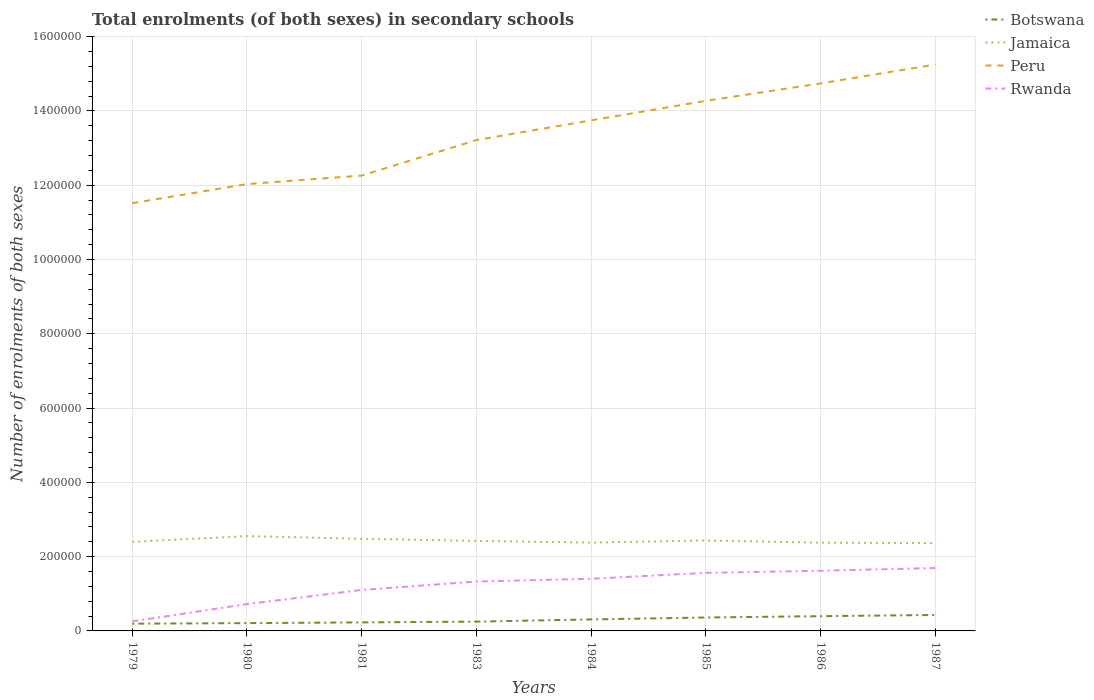Does the line corresponding to Jamaica intersect with the line corresponding to Botswana?
Provide a short and direct response. No. Is the number of lines equal to the number of legend labels?
Keep it short and to the point. Yes. Across all years, what is the maximum number of enrolments in secondary schools in Jamaica?
Keep it short and to the point. 2.36e+05. What is the total number of enrolments in secondary schools in Rwanda in the graph?
Your answer should be very brief. -1.15e+05. What is the difference between the highest and the second highest number of enrolments in secondary schools in Peru?
Ensure brevity in your answer.  3.73e+05. What is the difference between the highest and the lowest number of enrolments in secondary schools in Rwanda?
Your answer should be compact. 5. Is the number of enrolments in secondary schools in Peru strictly greater than the number of enrolments in secondary schools in Rwanda over the years?
Keep it short and to the point. No. Are the values on the major ticks of Y-axis written in scientific E-notation?
Provide a short and direct response. No. Where does the legend appear in the graph?
Keep it short and to the point. Top right. How are the legend labels stacked?
Give a very brief answer. Vertical. What is the title of the graph?
Make the answer very short. Total enrolments (of both sexes) in secondary schools. Does "High income: OECD" appear as one of the legend labels in the graph?
Your answer should be very brief. No. What is the label or title of the Y-axis?
Give a very brief answer. Number of enrolments of both sexes. What is the Number of enrolments of both sexes of Botswana in 1979?
Ensure brevity in your answer.  1.95e+04. What is the Number of enrolments of both sexes of Jamaica in 1979?
Offer a very short reply. 2.40e+05. What is the Number of enrolments of both sexes of Peru in 1979?
Provide a short and direct response. 1.15e+06. What is the Number of enrolments of both sexes of Rwanda in 1979?
Provide a succinct answer. 2.56e+04. What is the Number of enrolments of both sexes in Botswana in 1980?
Provide a short and direct response. 2.10e+04. What is the Number of enrolments of both sexes of Jamaica in 1980?
Offer a very short reply. 2.55e+05. What is the Number of enrolments of both sexes of Peru in 1980?
Your answer should be compact. 1.20e+06. What is the Number of enrolments of both sexes in Rwanda in 1980?
Your answer should be very brief. 7.22e+04. What is the Number of enrolments of both sexes in Botswana in 1981?
Offer a very short reply. 2.30e+04. What is the Number of enrolments of both sexes of Jamaica in 1981?
Keep it short and to the point. 2.48e+05. What is the Number of enrolments of both sexes in Peru in 1981?
Provide a succinct answer. 1.23e+06. What is the Number of enrolments of both sexes of Rwanda in 1981?
Your response must be concise. 1.10e+05. What is the Number of enrolments of both sexes in Botswana in 1983?
Your answer should be very brief. 2.50e+04. What is the Number of enrolments of both sexes of Jamaica in 1983?
Your answer should be very brief. 2.42e+05. What is the Number of enrolments of both sexes of Peru in 1983?
Your response must be concise. 1.32e+06. What is the Number of enrolments of both sexes of Rwanda in 1983?
Ensure brevity in your answer.  1.33e+05. What is the Number of enrolments of both sexes in Botswana in 1984?
Provide a short and direct response. 3.09e+04. What is the Number of enrolments of both sexes of Jamaica in 1984?
Provide a succinct answer. 2.38e+05. What is the Number of enrolments of both sexes of Peru in 1984?
Your answer should be very brief. 1.37e+06. What is the Number of enrolments of both sexes of Rwanda in 1984?
Provide a short and direct response. 1.40e+05. What is the Number of enrolments of both sexes of Botswana in 1985?
Make the answer very short. 3.61e+04. What is the Number of enrolments of both sexes in Jamaica in 1985?
Your answer should be compact. 2.44e+05. What is the Number of enrolments of both sexes in Peru in 1985?
Keep it short and to the point. 1.43e+06. What is the Number of enrolments of both sexes of Rwanda in 1985?
Offer a terse response. 1.56e+05. What is the Number of enrolments of both sexes in Botswana in 1986?
Keep it short and to the point. 3.97e+04. What is the Number of enrolments of both sexes of Jamaica in 1986?
Your answer should be compact. 2.38e+05. What is the Number of enrolments of both sexes in Peru in 1986?
Provide a succinct answer. 1.47e+06. What is the Number of enrolments of both sexes of Rwanda in 1986?
Your response must be concise. 1.62e+05. What is the Number of enrolments of both sexes of Botswana in 1987?
Your answer should be compact. 4.30e+04. What is the Number of enrolments of both sexes in Jamaica in 1987?
Your answer should be compact. 2.36e+05. What is the Number of enrolments of both sexes in Peru in 1987?
Your answer should be compact. 1.53e+06. What is the Number of enrolments of both sexes in Rwanda in 1987?
Provide a succinct answer. 1.69e+05. Across all years, what is the maximum Number of enrolments of both sexes of Botswana?
Make the answer very short. 4.30e+04. Across all years, what is the maximum Number of enrolments of both sexes of Jamaica?
Your answer should be very brief. 2.55e+05. Across all years, what is the maximum Number of enrolments of both sexes of Peru?
Offer a very short reply. 1.53e+06. Across all years, what is the maximum Number of enrolments of both sexes of Rwanda?
Your answer should be very brief. 1.69e+05. Across all years, what is the minimum Number of enrolments of both sexes of Botswana?
Your response must be concise. 1.95e+04. Across all years, what is the minimum Number of enrolments of both sexes in Jamaica?
Provide a short and direct response. 2.36e+05. Across all years, what is the minimum Number of enrolments of both sexes of Peru?
Ensure brevity in your answer.  1.15e+06. Across all years, what is the minimum Number of enrolments of both sexes in Rwanda?
Your answer should be very brief. 2.56e+04. What is the total Number of enrolments of both sexes of Botswana in the graph?
Keep it short and to the point. 2.38e+05. What is the total Number of enrolments of both sexes in Jamaica in the graph?
Make the answer very short. 1.94e+06. What is the total Number of enrolments of both sexes of Peru in the graph?
Offer a terse response. 1.07e+07. What is the total Number of enrolments of both sexes of Rwanda in the graph?
Offer a terse response. 9.69e+05. What is the difference between the Number of enrolments of both sexes of Botswana in 1979 and that in 1980?
Provide a succinct answer. -1431. What is the difference between the Number of enrolments of both sexes in Jamaica in 1979 and that in 1980?
Keep it short and to the point. -1.55e+04. What is the difference between the Number of enrolments of both sexes in Peru in 1979 and that in 1980?
Keep it short and to the point. -5.14e+04. What is the difference between the Number of enrolments of both sexes in Rwanda in 1979 and that in 1980?
Ensure brevity in your answer.  -4.66e+04. What is the difference between the Number of enrolments of both sexes in Botswana in 1979 and that in 1981?
Keep it short and to the point. -3424. What is the difference between the Number of enrolments of both sexes in Jamaica in 1979 and that in 1981?
Provide a short and direct response. -8242. What is the difference between the Number of enrolments of both sexes of Peru in 1979 and that in 1981?
Provide a short and direct response. -7.44e+04. What is the difference between the Number of enrolments of both sexes in Rwanda in 1979 and that in 1981?
Provide a short and direct response. -8.47e+04. What is the difference between the Number of enrolments of both sexes of Botswana in 1979 and that in 1983?
Offer a very short reply. -5472. What is the difference between the Number of enrolments of both sexes in Jamaica in 1979 and that in 1983?
Your response must be concise. -2630. What is the difference between the Number of enrolments of both sexes in Peru in 1979 and that in 1983?
Offer a very short reply. -1.70e+05. What is the difference between the Number of enrolments of both sexes in Rwanda in 1979 and that in 1983?
Ensure brevity in your answer.  -1.07e+05. What is the difference between the Number of enrolments of both sexes of Botswana in 1979 and that in 1984?
Provide a short and direct response. -1.14e+04. What is the difference between the Number of enrolments of both sexes of Jamaica in 1979 and that in 1984?
Keep it short and to the point. 2001. What is the difference between the Number of enrolments of both sexes of Peru in 1979 and that in 1984?
Offer a very short reply. -2.23e+05. What is the difference between the Number of enrolments of both sexes in Rwanda in 1979 and that in 1984?
Provide a succinct answer. -1.15e+05. What is the difference between the Number of enrolments of both sexes of Botswana in 1979 and that in 1985?
Offer a very short reply. -1.66e+04. What is the difference between the Number of enrolments of both sexes in Jamaica in 1979 and that in 1985?
Keep it short and to the point. -3816. What is the difference between the Number of enrolments of both sexes in Peru in 1979 and that in 1985?
Your answer should be compact. -2.76e+05. What is the difference between the Number of enrolments of both sexes of Rwanda in 1979 and that in 1985?
Keep it short and to the point. -1.31e+05. What is the difference between the Number of enrolments of both sexes in Botswana in 1979 and that in 1986?
Make the answer very short. -2.02e+04. What is the difference between the Number of enrolments of both sexes in Jamaica in 1979 and that in 1986?
Your response must be concise. 2046. What is the difference between the Number of enrolments of both sexes in Peru in 1979 and that in 1986?
Offer a very short reply. -3.22e+05. What is the difference between the Number of enrolments of both sexes in Rwanda in 1979 and that in 1986?
Offer a terse response. -1.36e+05. What is the difference between the Number of enrolments of both sexes in Botswana in 1979 and that in 1987?
Provide a succinct answer. -2.34e+04. What is the difference between the Number of enrolments of both sexes of Jamaica in 1979 and that in 1987?
Give a very brief answer. 3368. What is the difference between the Number of enrolments of both sexes of Peru in 1979 and that in 1987?
Provide a succinct answer. -3.73e+05. What is the difference between the Number of enrolments of both sexes of Rwanda in 1979 and that in 1987?
Ensure brevity in your answer.  -1.44e+05. What is the difference between the Number of enrolments of both sexes in Botswana in 1980 and that in 1981?
Make the answer very short. -1993. What is the difference between the Number of enrolments of both sexes of Jamaica in 1980 and that in 1981?
Your answer should be very brief. 7230. What is the difference between the Number of enrolments of both sexes of Peru in 1980 and that in 1981?
Offer a terse response. -2.30e+04. What is the difference between the Number of enrolments of both sexes in Rwanda in 1980 and that in 1981?
Your answer should be compact. -3.81e+04. What is the difference between the Number of enrolments of both sexes of Botswana in 1980 and that in 1983?
Your answer should be compact. -4041. What is the difference between the Number of enrolments of both sexes in Jamaica in 1980 and that in 1983?
Keep it short and to the point. 1.28e+04. What is the difference between the Number of enrolments of both sexes in Peru in 1980 and that in 1983?
Offer a terse response. -1.19e+05. What is the difference between the Number of enrolments of both sexes in Rwanda in 1980 and that in 1983?
Offer a terse response. -6.08e+04. What is the difference between the Number of enrolments of both sexes in Botswana in 1980 and that in 1984?
Keep it short and to the point. -9933. What is the difference between the Number of enrolments of both sexes of Jamaica in 1980 and that in 1984?
Give a very brief answer. 1.75e+04. What is the difference between the Number of enrolments of both sexes in Peru in 1980 and that in 1984?
Your answer should be compact. -1.72e+05. What is the difference between the Number of enrolments of both sexes in Rwanda in 1980 and that in 1984?
Provide a short and direct response. -6.83e+04. What is the difference between the Number of enrolments of both sexes of Botswana in 1980 and that in 1985?
Your answer should be compact. -1.52e+04. What is the difference between the Number of enrolments of both sexes of Jamaica in 1980 and that in 1985?
Your answer should be compact. 1.17e+04. What is the difference between the Number of enrolments of both sexes of Peru in 1980 and that in 1985?
Provide a short and direct response. -2.24e+05. What is the difference between the Number of enrolments of both sexes of Rwanda in 1980 and that in 1985?
Your answer should be compact. -8.41e+04. What is the difference between the Number of enrolments of both sexes of Botswana in 1980 and that in 1986?
Offer a terse response. -1.87e+04. What is the difference between the Number of enrolments of both sexes in Jamaica in 1980 and that in 1986?
Provide a succinct answer. 1.75e+04. What is the difference between the Number of enrolments of both sexes in Peru in 1980 and that in 1986?
Offer a terse response. -2.71e+05. What is the difference between the Number of enrolments of both sexes in Rwanda in 1980 and that in 1986?
Offer a terse response. -8.98e+04. What is the difference between the Number of enrolments of both sexes in Botswana in 1980 and that in 1987?
Keep it short and to the point. -2.20e+04. What is the difference between the Number of enrolments of both sexes of Jamaica in 1980 and that in 1987?
Your answer should be very brief. 1.88e+04. What is the difference between the Number of enrolments of both sexes in Peru in 1980 and that in 1987?
Your answer should be very brief. -3.22e+05. What is the difference between the Number of enrolments of both sexes in Rwanda in 1980 and that in 1987?
Provide a succinct answer. -9.71e+04. What is the difference between the Number of enrolments of both sexes of Botswana in 1981 and that in 1983?
Your response must be concise. -2048. What is the difference between the Number of enrolments of both sexes in Jamaica in 1981 and that in 1983?
Provide a short and direct response. 5612. What is the difference between the Number of enrolments of both sexes of Peru in 1981 and that in 1983?
Offer a very short reply. -9.55e+04. What is the difference between the Number of enrolments of both sexes in Rwanda in 1981 and that in 1983?
Offer a terse response. -2.27e+04. What is the difference between the Number of enrolments of both sexes of Botswana in 1981 and that in 1984?
Keep it short and to the point. -7940. What is the difference between the Number of enrolments of both sexes of Jamaica in 1981 and that in 1984?
Your answer should be very brief. 1.02e+04. What is the difference between the Number of enrolments of both sexes in Peru in 1981 and that in 1984?
Keep it short and to the point. -1.49e+05. What is the difference between the Number of enrolments of both sexes in Rwanda in 1981 and that in 1984?
Keep it short and to the point. -3.02e+04. What is the difference between the Number of enrolments of both sexes of Botswana in 1981 and that in 1985?
Ensure brevity in your answer.  -1.32e+04. What is the difference between the Number of enrolments of both sexes in Jamaica in 1981 and that in 1985?
Make the answer very short. 4426. What is the difference between the Number of enrolments of both sexes in Peru in 1981 and that in 1985?
Offer a terse response. -2.01e+05. What is the difference between the Number of enrolments of both sexes in Rwanda in 1981 and that in 1985?
Offer a very short reply. -4.60e+04. What is the difference between the Number of enrolments of both sexes in Botswana in 1981 and that in 1986?
Provide a short and direct response. -1.68e+04. What is the difference between the Number of enrolments of both sexes in Jamaica in 1981 and that in 1986?
Your answer should be compact. 1.03e+04. What is the difference between the Number of enrolments of both sexes in Peru in 1981 and that in 1986?
Ensure brevity in your answer.  -2.48e+05. What is the difference between the Number of enrolments of both sexes of Rwanda in 1981 and that in 1986?
Provide a succinct answer. -5.17e+04. What is the difference between the Number of enrolments of both sexes in Botswana in 1981 and that in 1987?
Your response must be concise. -2.00e+04. What is the difference between the Number of enrolments of both sexes in Jamaica in 1981 and that in 1987?
Provide a short and direct response. 1.16e+04. What is the difference between the Number of enrolments of both sexes of Peru in 1981 and that in 1987?
Offer a terse response. -2.99e+05. What is the difference between the Number of enrolments of both sexes of Rwanda in 1981 and that in 1987?
Your response must be concise. -5.90e+04. What is the difference between the Number of enrolments of both sexes of Botswana in 1983 and that in 1984?
Give a very brief answer. -5892. What is the difference between the Number of enrolments of both sexes of Jamaica in 1983 and that in 1984?
Provide a succinct answer. 4631. What is the difference between the Number of enrolments of both sexes in Peru in 1983 and that in 1984?
Your answer should be compact. -5.31e+04. What is the difference between the Number of enrolments of both sexes of Rwanda in 1983 and that in 1984?
Offer a terse response. -7480. What is the difference between the Number of enrolments of both sexes in Botswana in 1983 and that in 1985?
Offer a very short reply. -1.11e+04. What is the difference between the Number of enrolments of both sexes in Jamaica in 1983 and that in 1985?
Provide a succinct answer. -1186. What is the difference between the Number of enrolments of both sexes of Peru in 1983 and that in 1985?
Provide a short and direct response. -1.06e+05. What is the difference between the Number of enrolments of both sexes of Rwanda in 1983 and that in 1985?
Give a very brief answer. -2.33e+04. What is the difference between the Number of enrolments of both sexes of Botswana in 1983 and that in 1986?
Offer a terse response. -1.47e+04. What is the difference between the Number of enrolments of both sexes in Jamaica in 1983 and that in 1986?
Your response must be concise. 4676. What is the difference between the Number of enrolments of both sexes in Peru in 1983 and that in 1986?
Make the answer very short. -1.52e+05. What is the difference between the Number of enrolments of both sexes in Rwanda in 1983 and that in 1986?
Provide a short and direct response. -2.90e+04. What is the difference between the Number of enrolments of both sexes in Botswana in 1983 and that in 1987?
Your answer should be compact. -1.79e+04. What is the difference between the Number of enrolments of both sexes in Jamaica in 1983 and that in 1987?
Offer a terse response. 5998. What is the difference between the Number of enrolments of both sexes of Peru in 1983 and that in 1987?
Make the answer very short. -2.03e+05. What is the difference between the Number of enrolments of both sexes of Rwanda in 1983 and that in 1987?
Your answer should be compact. -3.64e+04. What is the difference between the Number of enrolments of both sexes of Botswana in 1984 and that in 1985?
Provide a short and direct response. -5242. What is the difference between the Number of enrolments of both sexes in Jamaica in 1984 and that in 1985?
Ensure brevity in your answer.  -5817. What is the difference between the Number of enrolments of both sexes of Peru in 1984 and that in 1985?
Provide a succinct answer. -5.25e+04. What is the difference between the Number of enrolments of both sexes in Rwanda in 1984 and that in 1985?
Provide a short and direct response. -1.59e+04. What is the difference between the Number of enrolments of both sexes in Botswana in 1984 and that in 1986?
Give a very brief answer. -8811. What is the difference between the Number of enrolments of both sexes in Jamaica in 1984 and that in 1986?
Your response must be concise. 45. What is the difference between the Number of enrolments of both sexes in Peru in 1984 and that in 1986?
Your answer should be compact. -9.94e+04. What is the difference between the Number of enrolments of both sexes in Rwanda in 1984 and that in 1986?
Your answer should be compact. -2.16e+04. What is the difference between the Number of enrolments of both sexes of Botswana in 1984 and that in 1987?
Give a very brief answer. -1.20e+04. What is the difference between the Number of enrolments of both sexes of Jamaica in 1984 and that in 1987?
Offer a terse response. 1367. What is the difference between the Number of enrolments of both sexes in Peru in 1984 and that in 1987?
Your answer should be very brief. -1.50e+05. What is the difference between the Number of enrolments of both sexes in Rwanda in 1984 and that in 1987?
Keep it short and to the point. -2.89e+04. What is the difference between the Number of enrolments of both sexes of Botswana in 1985 and that in 1986?
Your answer should be very brief. -3569. What is the difference between the Number of enrolments of both sexes in Jamaica in 1985 and that in 1986?
Offer a terse response. 5862. What is the difference between the Number of enrolments of both sexes of Peru in 1985 and that in 1986?
Keep it short and to the point. -4.69e+04. What is the difference between the Number of enrolments of both sexes in Rwanda in 1985 and that in 1986?
Your response must be concise. -5684. What is the difference between the Number of enrolments of both sexes in Botswana in 1985 and that in 1987?
Make the answer very short. -6808. What is the difference between the Number of enrolments of both sexes of Jamaica in 1985 and that in 1987?
Ensure brevity in your answer.  7184. What is the difference between the Number of enrolments of both sexes of Peru in 1985 and that in 1987?
Make the answer very short. -9.78e+04. What is the difference between the Number of enrolments of both sexes in Rwanda in 1985 and that in 1987?
Ensure brevity in your answer.  -1.30e+04. What is the difference between the Number of enrolments of both sexes of Botswana in 1986 and that in 1987?
Your answer should be very brief. -3239. What is the difference between the Number of enrolments of both sexes in Jamaica in 1986 and that in 1987?
Your answer should be very brief. 1322. What is the difference between the Number of enrolments of both sexes of Peru in 1986 and that in 1987?
Ensure brevity in your answer.  -5.09e+04. What is the difference between the Number of enrolments of both sexes in Rwanda in 1986 and that in 1987?
Provide a short and direct response. -7324. What is the difference between the Number of enrolments of both sexes of Botswana in 1979 and the Number of enrolments of both sexes of Jamaica in 1980?
Offer a terse response. -2.36e+05. What is the difference between the Number of enrolments of both sexes in Botswana in 1979 and the Number of enrolments of both sexes in Peru in 1980?
Your answer should be very brief. -1.18e+06. What is the difference between the Number of enrolments of both sexes in Botswana in 1979 and the Number of enrolments of both sexes in Rwanda in 1980?
Offer a very short reply. -5.27e+04. What is the difference between the Number of enrolments of both sexes of Jamaica in 1979 and the Number of enrolments of both sexes of Peru in 1980?
Offer a very short reply. -9.63e+05. What is the difference between the Number of enrolments of both sexes in Jamaica in 1979 and the Number of enrolments of both sexes in Rwanda in 1980?
Make the answer very short. 1.68e+05. What is the difference between the Number of enrolments of both sexes in Peru in 1979 and the Number of enrolments of both sexes in Rwanda in 1980?
Your answer should be very brief. 1.08e+06. What is the difference between the Number of enrolments of both sexes in Botswana in 1979 and the Number of enrolments of both sexes in Jamaica in 1981?
Provide a succinct answer. -2.28e+05. What is the difference between the Number of enrolments of both sexes in Botswana in 1979 and the Number of enrolments of both sexes in Peru in 1981?
Ensure brevity in your answer.  -1.21e+06. What is the difference between the Number of enrolments of both sexes of Botswana in 1979 and the Number of enrolments of both sexes of Rwanda in 1981?
Offer a terse response. -9.08e+04. What is the difference between the Number of enrolments of both sexes in Jamaica in 1979 and the Number of enrolments of both sexes in Peru in 1981?
Offer a terse response. -9.86e+05. What is the difference between the Number of enrolments of both sexes of Jamaica in 1979 and the Number of enrolments of both sexes of Rwanda in 1981?
Give a very brief answer. 1.29e+05. What is the difference between the Number of enrolments of both sexes of Peru in 1979 and the Number of enrolments of both sexes of Rwanda in 1981?
Your answer should be very brief. 1.04e+06. What is the difference between the Number of enrolments of both sexes of Botswana in 1979 and the Number of enrolments of both sexes of Jamaica in 1983?
Your answer should be very brief. -2.23e+05. What is the difference between the Number of enrolments of both sexes of Botswana in 1979 and the Number of enrolments of both sexes of Peru in 1983?
Offer a very short reply. -1.30e+06. What is the difference between the Number of enrolments of both sexes of Botswana in 1979 and the Number of enrolments of both sexes of Rwanda in 1983?
Make the answer very short. -1.13e+05. What is the difference between the Number of enrolments of both sexes of Jamaica in 1979 and the Number of enrolments of both sexes of Peru in 1983?
Your response must be concise. -1.08e+06. What is the difference between the Number of enrolments of both sexes in Jamaica in 1979 and the Number of enrolments of both sexes in Rwanda in 1983?
Provide a succinct answer. 1.07e+05. What is the difference between the Number of enrolments of both sexes in Peru in 1979 and the Number of enrolments of both sexes in Rwanda in 1983?
Your response must be concise. 1.02e+06. What is the difference between the Number of enrolments of both sexes in Botswana in 1979 and the Number of enrolments of both sexes in Jamaica in 1984?
Your answer should be compact. -2.18e+05. What is the difference between the Number of enrolments of both sexes of Botswana in 1979 and the Number of enrolments of both sexes of Peru in 1984?
Your answer should be compact. -1.36e+06. What is the difference between the Number of enrolments of both sexes in Botswana in 1979 and the Number of enrolments of both sexes in Rwanda in 1984?
Keep it short and to the point. -1.21e+05. What is the difference between the Number of enrolments of both sexes in Jamaica in 1979 and the Number of enrolments of both sexes in Peru in 1984?
Make the answer very short. -1.14e+06. What is the difference between the Number of enrolments of both sexes in Jamaica in 1979 and the Number of enrolments of both sexes in Rwanda in 1984?
Your response must be concise. 9.93e+04. What is the difference between the Number of enrolments of both sexes in Peru in 1979 and the Number of enrolments of both sexes in Rwanda in 1984?
Provide a succinct answer. 1.01e+06. What is the difference between the Number of enrolments of both sexes of Botswana in 1979 and the Number of enrolments of both sexes of Jamaica in 1985?
Offer a terse response. -2.24e+05. What is the difference between the Number of enrolments of both sexes in Botswana in 1979 and the Number of enrolments of both sexes in Peru in 1985?
Your answer should be compact. -1.41e+06. What is the difference between the Number of enrolments of both sexes in Botswana in 1979 and the Number of enrolments of both sexes in Rwanda in 1985?
Your answer should be compact. -1.37e+05. What is the difference between the Number of enrolments of both sexes in Jamaica in 1979 and the Number of enrolments of both sexes in Peru in 1985?
Provide a short and direct response. -1.19e+06. What is the difference between the Number of enrolments of both sexes of Jamaica in 1979 and the Number of enrolments of both sexes of Rwanda in 1985?
Your answer should be compact. 8.34e+04. What is the difference between the Number of enrolments of both sexes in Peru in 1979 and the Number of enrolments of both sexes in Rwanda in 1985?
Your answer should be very brief. 9.95e+05. What is the difference between the Number of enrolments of both sexes in Botswana in 1979 and the Number of enrolments of both sexes in Jamaica in 1986?
Provide a succinct answer. -2.18e+05. What is the difference between the Number of enrolments of both sexes of Botswana in 1979 and the Number of enrolments of both sexes of Peru in 1986?
Offer a very short reply. -1.45e+06. What is the difference between the Number of enrolments of both sexes of Botswana in 1979 and the Number of enrolments of both sexes of Rwanda in 1986?
Ensure brevity in your answer.  -1.42e+05. What is the difference between the Number of enrolments of both sexes of Jamaica in 1979 and the Number of enrolments of both sexes of Peru in 1986?
Keep it short and to the point. -1.23e+06. What is the difference between the Number of enrolments of both sexes of Jamaica in 1979 and the Number of enrolments of both sexes of Rwanda in 1986?
Your answer should be compact. 7.77e+04. What is the difference between the Number of enrolments of both sexes in Peru in 1979 and the Number of enrolments of both sexes in Rwanda in 1986?
Offer a very short reply. 9.90e+05. What is the difference between the Number of enrolments of both sexes in Botswana in 1979 and the Number of enrolments of both sexes in Jamaica in 1987?
Your answer should be compact. -2.17e+05. What is the difference between the Number of enrolments of both sexes of Botswana in 1979 and the Number of enrolments of both sexes of Peru in 1987?
Ensure brevity in your answer.  -1.51e+06. What is the difference between the Number of enrolments of both sexes in Botswana in 1979 and the Number of enrolments of both sexes in Rwanda in 1987?
Make the answer very short. -1.50e+05. What is the difference between the Number of enrolments of both sexes in Jamaica in 1979 and the Number of enrolments of both sexes in Peru in 1987?
Your answer should be compact. -1.29e+06. What is the difference between the Number of enrolments of both sexes in Jamaica in 1979 and the Number of enrolments of both sexes in Rwanda in 1987?
Provide a short and direct response. 7.04e+04. What is the difference between the Number of enrolments of both sexes in Peru in 1979 and the Number of enrolments of both sexes in Rwanda in 1987?
Ensure brevity in your answer.  9.82e+05. What is the difference between the Number of enrolments of both sexes of Botswana in 1980 and the Number of enrolments of both sexes of Jamaica in 1981?
Make the answer very short. -2.27e+05. What is the difference between the Number of enrolments of both sexes of Botswana in 1980 and the Number of enrolments of both sexes of Peru in 1981?
Ensure brevity in your answer.  -1.21e+06. What is the difference between the Number of enrolments of both sexes of Botswana in 1980 and the Number of enrolments of both sexes of Rwanda in 1981?
Ensure brevity in your answer.  -8.93e+04. What is the difference between the Number of enrolments of both sexes in Jamaica in 1980 and the Number of enrolments of both sexes in Peru in 1981?
Your response must be concise. -9.71e+05. What is the difference between the Number of enrolments of both sexes in Jamaica in 1980 and the Number of enrolments of both sexes in Rwanda in 1981?
Give a very brief answer. 1.45e+05. What is the difference between the Number of enrolments of both sexes in Peru in 1980 and the Number of enrolments of both sexes in Rwanda in 1981?
Ensure brevity in your answer.  1.09e+06. What is the difference between the Number of enrolments of both sexes of Botswana in 1980 and the Number of enrolments of both sexes of Jamaica in 1983?
Ensure brevity in your answer.  -2.21e+05. What is the difference between the Number of enrolments of both sexes of Botswana in 1980 and the Number of enrolments of both sexes of Peru in 1983?
Ensure brevity in your answer.  -1.30e+06. What is the difference between the Number of enrolments of both sexes in Botswana in 1980 and the Number of enrolments of both sexes in Rwanda in 1983?
Your response must be concise. -1.12e+05. What is the difference between the Number of enrolments of both sexes of Jamaica in 1980 and the Number of enrolments of both sexes of Peru in 1983?
Provide a succinct answer. -1.07e+06. What is the difference between the Number of enrolments of both sexes of Jamaica in 1980 and the Number of enrolments of both sexes of Rwanda in 1983?
Keep it short and to the point. 1.22e+05. What is the difference between the Number of enrolments of both sexes in Peru in 1980 and the Number of enrolments of both sexes in Rwanda in 1983?
Your response must be concise. 1.07e+06. What is the difference between the Number of enrolments of both sexes in Botswana in 1980 and the Number of enrolments of both sexes in Jamaica in 1984?
Offer a very short reply. -2.17e+05. What is the difference between the Number of enrolments of both sexes of Botswana in 1980 and the Number of enrolments of both sexes of Peru in 1984?
Give a very brief answer. -1.35e+06. What is the difference between the Number of enrolments of both sexes in Botswana in 1980 and the Number of enrolments of both sexes in Rwanda in 1984?
Provide a succinct answer. -1.20e+05. What is the difference between the Number of enrolments of both sexes in Jamaica in 1980 and the Number of enrolments of both sexes in Peru in 1984?
Your answer should be compact. -1.12e+06. What is the difference between the Number of enrolments of both sexes of Jamaica in 1980 and the Number of enrolments of both sexes of Rwanda in 1984?
Provide a succinct answer. 1.15e+05. What is the difference between the Number of enrolments of both sexes of Peru in 1980 and the Number of enrolments of both sexes of Rwanda in 1984?
Provide a succinct answer. 1.06e+06. What is the difference between the Number of enrolments of both sexes of Botswana in 1980 and the Number of enrolments of both sexes of Jamaica in 1985?
Your response must be concise. -2.23e+05. What is the difference between the Number of enrolments of both sexes in Botswana in 1980 and the Number of enrolments of both sexes in Peru in 1985?
Ensure brevity in your answer.  -1.41e+06. What is the difference between the Number of enrolments of both sexes of Botswana in 1980 and the Number of enrolments of both sexes of Rwanda in 1985?
Provide a succinct answer. -1.35e+05. What is the difference between the Number of enrolments of both sexes in Jamaica in 1980 and the Number of enrolments of both sexes in Peru in 1985?
Provide a succinct answer. -1.17e+06. What is the difference between the Number of enrolments of both sexes of Jamaica in 1980 and the Number of enrolments of both sexes of Rwanda in 1985?
Provide a succinct answer. 9.89e+04. What is the difference between the Number of enrolments of both sexes in Peru in 1980 and the Number of enrolments of both sexes in Rwanda in 1985?
Give a very brief answer. 1.05e+06. What is the difference between the Number of enrolments of both sexes of Botswana in 1980 and the Number of enrolments of both sexes of Jamaica in 1986?
Your answer should be very brief. -2.17e+05. What is the difference between the Number of enrolments of both sexes of Botswana in 1980 and the Number of enrolments of both sexes of Peru in 1986?
Offer a very short reply. -1.45e+06. What is the difference between the Number of enrolments of both sexes in Botswana in 1980 and the Number of enrolments of both sexes in Rwanda in 1986?
Provide a short and direct response. -1.41e+05. What is the difference between the Number of enrolments of both sexes of Jamaica in 1980 and the Number of enrolments of both sexes of Peru in 1986?
Provide a short and direct response. -1.22e+06. What is the difference between the Number of enrolments of both sexes in Jamaica in 1980 and the Number of enrolments of both sexes in Rwanda in 1986?
Give a very brief answer. 9.32e+04. What is the difference between the Number of enrolments of both sexes in Peru in 1980 and the Number of enrolments of both sexes in Rwanda in 1986?
Your answer should be very brief. 1.04e+06. What is the difference between the Number of enrolments of both sexes of Botswana in 1980 and the Number of enrolments of both sexes of Jamaica in 1987?
Offer a terse response. -2.15e+05. What is the difference between the Number of enrolments of both sexes in Botswana in 1980 and the Number of enrolments of both sexes in Peru in 1987?
Your answer should be compact. -1.50e+06. What is the difference between the Number of enrolments of both sexes of Botswana in 1980 and the Number of enrolments of both sexes of Rwanda in 1987?
Ensure brevity in your answer.  -1.48e+05. What is the difference between the Number of enrolments of both sexes of Jamaica in 1980 and the Number of enrolments of both sexes of Peru in 1987?
Provide a short and direct response. -1.27e+06. What is the difference between the Number of enrolments of both sexes in Jamaica in 1980 and the Number of enrolments of both sexes in Rwanda in 1987?
Offer a very short reply. 8.59e+04. What is the difference between the Number of enrolments of both sexes of Peru in 1980 and the Number of enrolments of both sexes of Rwanda in 1987?
Keep it short and to the point. 1.03e+06. What is the difference between the Number of enrolments of both sexes in Botswana in 1981 and the Number of enrolments of both sexes in Jamaica in 1983?
Make the answer very short. -2.19e+05. What is the difference between the Number of enrolments of both sexes in Botswana in 1981 and the Number of enrolments of both sexes in Peru in 1983?
Offer a very short reply. -1.30e+06. What is the difference between the Number of enrolments of both sexes in Botswana in 1981 and the Number of enrolments of both sexes in Rwanda in 1983?
Ensure brevity in your answer.  -1.10e+05. What is the difference between the Number of enrolments of both sexes in Jamaica in 1981 and the Number of enrolments of both sexes in Peru in 1983?
Your answer should be very brief. -1.07e+06. What is the difference between the Number of enrolments of both sexes in Jamaica in 1981 and the Number of enrolments of both sexes in Rwanda in 1983?
Give a very brief answer. 1.15e+05. What is the difference between the Number of enrolments of both sexes in Peru in 1981 and the Number of enrolments of both sexes in Rwanda in 1983?
Give a very brief answer. 1.09e+06. What is the difference between the Number of enrolments of both sexes of Botswana in 1981 and the Number of enrolments of both sexes of Jamaica in 1984?
Offer a terse response. -2.15e+05. What is the difference between the Number of enrolments of both sexes of Botswana in 1981 and the Number of enrolments of both sexes of Peru in 1984?
Your answer should be very brief. -1.35e+06. What is the difference between the Number of enrolments of both sexes in Botswana in 1981 and the Number of enrolments of both sexes in Rwanda in 1984?
Your response must be concise. -1.18e+05. What is the difference between the Number of enrolments of both sexes in Jamaica in 1981 and the Number of enrolments of both sexes in Peru in 1984?
Provide a succinct answer. -1.13e+06. What is the difference between the Number of enrolments of both sexes of Jamaica in 1981 and the Number of enrolments of both sexes of Rwanda in 1984?
Your answer should be very brief. 1.08e+05. What is the difference between the Number of enrolments of both sexes of Peru in 1981 and the Number of enrolments of both sexes of Rwanda in 1984?
Keep it short and to the point. 1.09e+06. What is the difference between the Number of enrolments of both sexes in Botswana in 1981 and the Number of enrolments of both sexes in Jamaica in 1985?
Keep it short and to the point. -2.21e+05. What is the difference between the Number of enrolments of both sexes of Botswana in 1981 and the Number of enrolments of both sexes of Peru in 1985?
Your answer should be very brief. -1.40e+06. What is the difference between the Number of enrolments of both sexes of Botswana in 1981 and the Number of enrolments of both sexes of Rwanda in 1985?
Offer a very short reply. -1.33e+05. What is the difference between the Number of enrolments of both sexes in Jamaica in 1981 and the Number of enrolments of both sexes in Peru in 1985?
Provide a succinct answer. -1.18e+06. What is the difference between the Number of enrolments of both sexes of Jamaica in 1981 and the Number of enrolments of both sexes of Rwanda in 1985?
Your response must be concise. 9.17e+04. What is the difference between the Number of enrolments of both sexes in Peru in 1981 and the Number of enrolments of both sexes in Rwanda in 1985?
Give a very brief answer. 1.07e+06. What is the difference between the Number of enrolments of both sexes in Botswana in 1981 and the Number of enrolments of both sexes in Jamaica in 1986?
Offer a terse response. -2.15e+05. What is the difference between the Number of enrolments of both sexes of Botswana in 1981 and the Number of enrolments of both sexes of Peru in 1986?
Your answer should be compact. -1.45e+06. What is the difference between the Number of enrolments of both sexes of Botswana in 1981 and the Number of enrolments of both sexes of Rwanda in 1986?
Ensure brevity in your answer.  -1.39e+05. What is the difference between the Number of enrolments of both sexes in Jamaica in 1981 and the Number of enrolments of both sexes in Peru in 1986?
Your answer should be very brief. -1.23e+06. What is the difference between the Number of enrolments of both sexes in Jamaica in 1981 and the Number of enrolments of both sexes in Rwanda in 1986?
Keep it short and to the point. 8.60e+04. What is the difference between the Number of enrolments of both sexes in Peru in 1981 and the Number of enrolments of both sexes in Rwanda in 1986?
Make the answer very short. 1.06e+06. What is the difference between the Number of enrolments of both sexes in Botswana in 1981 and the Number of enrolments of both sexes in Jamaica in 1987?
Provide a short and direct response. -2.13e+05. What is the difference between the Number of enrolments of both sexes in Botswana in 1981 and the Number of enrolments of both sexes in Peru in 1987?
Provide a succinct answer. -1.50e+06. What is the difference between the Number of enrolments of both sexes in Botswana in 1981 and the Number of enrolments of both sexes in Rwanda in 1987?
Provide a succinct answer. -1.46e+05. What is the difference between the Number of enrolments of both sexes in Jamaica in 1981 and the Number of enrolments of both sexes in Peru in 1987?
Give a very brief answer. -1.28e+06. What is the difference between the Number of enrolments of both sexes in Jamaica in 1981 and the Number of enrolments of both sexes in Rwanda in 1987?
Make the answer very short. 7.86e+04. What is the difference between the Number of enrolments of both sexes in Peru in 1981 and the Number of enrolments of both sexes in Rwanda in 1987?
Offer a terse response. 1.06e+06. What is the difference between the Number of enrolments of both sexes in Botswana in 1983 and the Number of enrolments of both sexes in Jamaica in 1984?
Provide a short and direct response. -2.13e+05. What is the difference between the Number of enrolments of both sexes of Botswana in 1983 and the Number of enrolments of both sexes of Peru in 1984?
Make the answer very short. -1.35e+06. What is the difference between the Number of enrolments of both sexes of Botswana in 1983 and the Number of enrolments of both sexes of Rwanda in 1984?
Provide a succinct answer. -1.15e+05. What is the difference between the Number of enrolments of both sexes of Jamaica in 1983 and the Number of enrolments of both sexes of Peru in 1984?
Keep it short and to the point. -1.13e+06. What is the difference between the Number of enrolments of both sexes of Jamaica in 1983 and the Number of enrolments of both sexes of Rwanda in 1984?
Provide a short and direct response. 1.02e+05. What is the difference between the Number of enrolments of both sexes of Peru in 1983 and the Number of enrolments of both sexes of Rwanda in 1984?
Provide a succinct answer. 1.18e+06. What is the difference between the Number of enrolments of both sexes in Botswana in 1983 and the Number of enrolments of both sexes in Jamaica in 1985?
Your answer should be very brief. -2.19e+05. What is the difference between the Number of enrolments of both sexes of Botswana in 1983 and the Number of enrolments of both sexes of Peru in 1985?
Offer a very short reply. -1.40e+06. What is the difference between the Number of enrolments of both sexes in Botswana in 1983 and the Number of enrolments of both sexes in Rwanda in 1985?
Provide a short and direct response. -1.31e+05. What is the difference between the Number of enrolments of both sexes of Jamaica in 1983 and the Number of enrolments of both sexes of Peru in 1985?
Provide a succinct answer. -1.18e+06. What is the difference between the Number of enrolments of both sexes in Jamaica in 1983 and the Number of enrolments of both sexes in Rwanda in 1985?
Offer a very short reply. 8.60e+04. What is the difference between the Number of enrolments of both sexes of Peru in 1983 and the Number of enrolments of both sexes of Rwanda in 1985?
Provide a succinct answer. 1.17e+06. What is the difference between the Number of enrolments of both sexes of Botswana in 1983 and the Number of enrolments of both sexes of Jamaica in 1986?
Ensure brevity in your answer.  -2.13e+05. What is the difference between the Number of enrolments of both sexes of Botswana in 1983 and the Number of enrolments of both sexes of Peru in 1986?
Give a very brief answer. -1.45e+06. What is the difference between the Number of enrolments of both sexes of Botswana in 1983 and the Number of enrolments of both sexes of Rwanda in 1986?
Your answer should be compact. -1.37e+05. What is the difference between the Number of enrolments of both sexes of Jamaica in 1983 and the Number of enrolments of both sexes of Peru in 1986?
Your answer should be very brief. -1.23e+06. What is the difference between the Number of enrolments of both sexes in Jamaica in 1983 and the Number of enrolments of both sexes in Rwanda in 1986?
Provide a succinct answer. 8.04e+04. What is the difference between the Number of enrolments of both sexes of Peru in 1983 and the Number of enrolments of both sexes of Rwanda in 1986?
Ensure brevity in your answer.  1.16e+06. What is the difference between the Number of enrolments of both sexes in Botswana in 1983 and the Number of enrolments of both sexes in Jamaica in 1987?
Keep it short and to the point. -2.11e+05. What is the difference between the Number of enrolments of both sexes of Botswana in 1983 and the Number of enrolments of both sexes of Peru in 1987?
Your answer should be compact. -1.50e+06. What is the difference between the Number of enrolments of both sexes of Botswana in 1983 and the Number of enrolments of both sexes of Rwanda in 1987?
Your answer should be compact. -1.44e+05. What is the difference between the Number of enrolments of both sexes of Jamaica in 1983 and the Number of enrolments of both sexes of Peru in 1987?
Make the answer very short. -1.28e+06. What is the difference between the Number of enrolments of both sexes of Jamaica in 1983 and the Number of enrolments of both sexes of Rwanda in 1987?
Your answer should be very brief. 7.30e+04. What is the difference between the Number of enrolments of both sexes in Peru in 1983 and the Number of enrolments of both sexes in Rwanda in 1987?
Your answer should be very brief. 1.15e+06. What is the difference between the Number of enrolments of both sexes of Botswana in 1984 and the Number of enrolments of both sexes of Jamaica in 1985?
Your answer should be compact. -2.13e+05. What is the difference between the Number of enrolments of both sexes in Botswana in 1984 and the Number of enrolments of both sexes in Peru in 1985?
Give a very brief answer. -1.40e+06. What is the difference between the Number of enrolments of both sexes of Botswana in 1984 and the Number of enrolments of both sexes of Rwanda in 1985?
Make the answer very short. -1.25e+05. What is the difference between the Number of enrolments of both sexes in Jamaica in 1984 and the Number of enrolments of both sexes in Peru in 1985?
Provide a succinct answer. -1.19e+06. What is the difference between the Number of enrolments of both sexes in Jamaica in 1984 and the Number of enrolments of both sexes in Rwanda in 1985?
Offer a terse response. 8.14e+04. What is the difference between the Number of enrolments of both sexes in Peru in 1984 and the Number of enrolments of both sexes in Rwanda in 1985?
Your response must be concise. 1.22e+06. What is the difference between the Number of enrolments of both sexes in Botswana in 1984 and the Number of enrolments of both sexes in Jamaica in 1986?
Make the answer very short. -2.07e+05. What is the difference between the Number of enrolments of both sexes in Botswana in 1984 and the Number of enrolments of both sexes in Peru in 1986?
Make the answer very short. -1.44e+06. What is the difference between the Number of enrolments of both sexes in Botswana in 1984 and the Number of enrolments of both sexes in Rwanda in 1986?
Your answer should be very brief. -1.31e+05. What is the difference between the Number of enrolments of both sexes in Jamaica in 1984 and the Number of enrolments of both sexes in Peru in 1986?
Ensure brevity in your answer.  -1.24e+06. What is the difference between the Number of enrolments of both sexes in Jamaica in 1984 and the Number of enrolments of both sexes in Rwanda in 1986?
Offer a very short reply. 7.57e+04. What is the difference between the Number of enrolments of both sexes in Peru in 1984 and the Number of enrolments of both sexes in Rwanda in 1986?
Offer a terse response. 1.21e+06. What is the difference between the Number of enrolments of both sexes of Botswana in 1984 and the Number of enrolments of both sexes of Jamaica in 1987?
Provide a short and direct response. -2.05e+05. What is the difference between the Number of enrolments of both sexes in Botswana in 1984 and the Number of enrolments of both sexes in Peru in 1987?
Ensure brevity in your answer.  -1.49e+06. What is the difference between the Number of enrolments of both sexes of Botswana in 1984 and the Number of enrolments of both sexes of Rwanda in 1987?
Provide a succinct answer. -1.38e+05. What is the difference between the Number of enrolments of both sexes in Jamaica in 1984 and the Number of enrolments of both sexes in Peru in 1987?
Provide a short and direct response. -1.29e+06. What is the difference between the Number of enrolments of both sexes of Jamaica in 1984 and the Number of enrolments of both sexes of Rwanda in 1987?
Make the answer very short. 6.84e+04. What is the difference between the Number of enrolments of both sexes of Peru in 1984 and the Number of enrolments of both sexes of Rwanda in 1987?
Offer a terse response. 1.21e+06. What is the difference between the Number of enrolments of both sexes of Botswana in 1985 and the Number of enrolments of both sexes of Jamaica in 1986?
Your response must be concise. -2.02e+05. What is the difference between the Number of enrolments of both sexes of Botswana in 1985 and the Number of enrolments of both sexes of Peru in 1986?
Keep it short and to the point. -1.44e+06. What is the difference between the Number of enrolments of both sexes of Botswana in 1985 and the Number of enrolments of both sexes of Rwanda in 1986?
Offer a terse response. -1.26e+05. What is the difference between the Number of enrolments of both sexes in Jamaica in 1985 and the Number of enrolments of both sexes in Peru in 1986?
Provide a succinct answer. -1.23e+06. What is the difference between the Number of enrolments of both sexes of Jamaica in 1985 and the Number of enrolments of both sexes of Rwanda in 1986?
Offer a very short reply. 8.15e+04. What is the difference between the Number of enrolments of both sexes in Peru in 1985 and the Number of enrolments of both sexes in Rwanda in 1986?
Keep it short and to the point. 1.27e+06. What is the difference between the Number of enrolments of both sexes in Botswana in 1985 and the Number of enrolments of both sexes in Jamaica in 1987?
Your answer should be very brief. -2.00e+05. What is the difference between the Number of enrolments of both sexes of Botswana in 1985 and the Number of enrolments of both sexes of Peru in 1987?
Your answer should be very brief. -1.49e+06. What is the difference between the Number of enrolments of both sexes in Botswana in 1985 and the Number of enrolments of both sexes in Rwanda in 1987?
Offer a terse response. -1.33e+05. What is the difference between the Number of enrolments of both sexes in Jamaica in 1985 and the Number of enrolments of both sexes in Peru in 1987?
Make the answer very short. -1.28e+06. What is the difference between the Number of enrolments of both sexes of Jamaica in 1985 and the Number of enrolments of both sexes of Rwanda in 1987?
Provide a succinct answer. 7.42e+04. What is the difference between the Number of enrolments of both sexes of Peru in 1985 and the Number of enrolments of both sexes of Rwanda in 1987?
Offer a very short reply. 1.26e+06. What is the difference between the Number of enrolments of both sexes of Botswana in 1986 and the Number of enrolments of both sexes of Jamaica in 1987?
Provide a short and direct response. -1.97e+05. What is the difference between the Number of enrolments of both sexes in Botswana in 1986 and the Number of enrolments of both sexes in Peru in 1987?
Offer a terse response. -1.49e+06. What is the difference between the Number of enrolments of both sexes in Botswana in 1986 and the Number of enrolments of both sexes in Rwanda in 1987?
Offer a very short reply. -1.30e+05. What is the difference between the Number of enrolments of both sexes of Jamaica in 1986 and the Number of enrolments of both sexes of Peru in 1987?
Provide a short and direct response. -1.29e+06. What is the difference between the Number of enrolments of both sexes of Jamaica in 1986 and the Number of enrolments of both sexes of Rwanda in 1987?
Make the answer very short. 6.84e+04. What is the difference between the Number of enrolments of both sexes of Peru in 1986 and the Number of enrolments of both sexes of Rwanda in 1987?
Give a very brief answer. 1.30e+06. What is the average Number of enrolments of both sexes of Botswana per year?
Offer a terse response. 2.98e+04. What is the average Number of enrolments of both sexes in Jamaica per year?
Give a very brief answer. 2.43e+05. What is the average Number of enrolments of both sexes in Peru per year?
Offer a terse response. 1.34e+06. What is the average Number of enrolments of both sexes of Rwanda per year?
Make the answer very short. 1.21e+05. In the year 1979, what is the difference between the Number of enrolments of both sexes of Botswana and Number of enrolments of both sexes of Jamaica?
Your response must be concise. -2.20e+05. In the year 1979, what is the difference between the Number of enrolments of both sexes of Botswana and Number of enrolments of both sexes of Peru?
Give a very brief answer. -1.13e+06. In the year 1979, what is the difference between the Number of enrolments of both sexes of Botswana and Number of enrolments of both sexes of Rwanda?
Provide a succinct answer. -6063. In the year 1979, what is the difference between the Number of enrolments of both sexes in Jamaica and Number of enrolments of both sexes in Peru?
Offer a terse response. -9.12e+05. In the year 1979, what is the difference between the Number of enrolments of both sexes in Jamaica and Number of enrolments of both sexes in Rwanda?
Ensure brevity in your answer.  2.14e+05. In the year 1979, what is the difference between the Number of enrolments of both sexes of Peru and Number of enrolments of both sexes of Rwanda?
Keep it short and to the point. 1.13e+06. In the year 1980, what is the difference between the Number of enrolments of both sexes in Botswana and Number of enrolments of both sexes in Jamaica?
Offer a terse response. -2.34e+05. In the year 1980, what is the difference between the Number of enrolments of both sexes of Botswana and Number of enrolments of both sexes of Peru?
Your response must be concise. -1.18e+06. In the year 1980, what is the difference between the Number of enrolments of both sexes of Botswana and Number of enrolments of both sexes of Rwanda?
Offer a very short reply. -5.12e+04. In the year 1980, what is the difference between the Number of enrolments of both sexes of Jamaica and Number of enrolments of both sexes of Peru?
Provide a succinct answer. -9.48e+05. In the year 1980, what is the difference between the Number of enrolments of both sexes in Jamaica and Number of enrolments of both sexes in Rwanda?
Your answer should be compact. 1.83e+05. In the year 1980, what is the difference between the Number of enrolments of both sexes of Peru and Number of enrolments of both sexes of Rwanda?
Offer a terse response. 1.13e+06. In the year 1981, what is the difference between the Number of enrolments of both sexes of Botswana and Number of enrolments of both sexes of Jamaica?
Offer a very short reply. -2.25e+05. In the year 1981, what is the difference between the Number of enrolments of both sexes in Botswana and Number of enrolments of both sexes in Peru?
Your response must be concise. -1.20e+06. In the year 1981, what is the difference between the Number of enrolments of both sexes in Botswana and Number of enrolments of both sexes in Rwanda?
Provide a short and direct response. -8.74e+04. In the year 1981, what is the difference between the Number of enrolments of both sexes of Jamaica and Number of enrolments of both sexes of Peru?
Provide a succinct answer. -9.78e+05. In the year 1981, what is the difference between the Number of enrolments of both sexes in Jamaica and Number of enrolments of both sexes in Rwanda?
Make the answer very short. 1.38e+05. In the year 1981, what is the difference between the Number of enrolments of both sexes in Peru and Number of enrolments of both sexes in Rwanda?
Keep it short and to the point. 1.12e+06. In the year 1983, what is the difference between the Number of enrolments of both sexes of Botswana and Number of enrolments of both sexes of Jamaica?
Make the answer very short. -2.17e+05. In the year 1983, what is the difference between the Number of enrolments of both sexes in Botswana and Number of enrolments of both sexes in Peru?
Make the answer very short. -1.30e+06. In the year 1983, what is the difference between the Number of enrolments of both sexes in Botswana and Number of enrolments of both sexes in Rwanda?
Your answer should be very brief. -1.08e+05. In the year 1983, what is the difference between the Number of enrolments of both sexes in Jamaica and Number of enrolments of both sexes in Peru?
Your answer should be very brief. -1.08e+06. In the year 1983, what is the difference between the Number of enrolments of both sexes of Jamaica and Number of enrolments of both sexes of Rwanda?
Ensure brevity in your answer.  1.09e+05. In the year 1983, what is the difference between the Number of enrolments of both sexes in Peru and Number of enrolments of both sexes in Rwanda?
Provide a succinct answer. 1.19e+06. In the year 1984, what is the difference between the Number of enrolments of both sexes of Botswana and Number of enrolments of both sexes of Jamaica?
Keep it short and to the point. -2.07e+05. In the year 1984, what is the difference between the Number of enrolments of both sexes in Botswana and Number of enrolments of both sexes in Peru?
Your answer should be very brief. -1.34e+06. In the year 1984, what is the difference between the Number of enrolments of both sexes in Botswana and Number of enrolments of both sexes in Rwanda?
Offer a terse response. -1.10e+05. In the year 1984, what is the difference between the Number of enrolments of both sexes of Jamaica and Number of enrolments of both sexes of Peru?
Ensure brevity in your answer.  -1.14e+06. In the year 1984, what is the difference between the Number of enrolments of both sexes of Jamaica and Number of enrolments of both sexes of Rwanda?
Offer a terse response. 9.73e+04. In the year 1984, what is the difference between the Number of enrolments of both sexes of Peru and Number of enrolments of both sexes of Rwanda?
Ensure brevity in your answer.  1.23e+06. In the year 1985, what is the difference between the Number of enrolments of both sexes of Botswana and Number of enrolments of both sexes of Jamaica?
Make the answer very short. -2.07e+05. In the year 1985, what is the difference between the Number of enrolments of both sexes in Botswana and Number of enrolments of both sexes in Peru?
Your response must be concise. -1.39e+06. In the year 1985, what is the difference between the Number of enrolments of both sexes in Botswana and Number of enrolments of both sexes in Rwanda?
Offer a very short reply. -1.20e+05. In the year 1985, what is the difference between the Number of enrolments of both sexes in Jamaica and Number of enrolments of both sexes in Peru?
Provide a succinct answer. -1.18e+06. In the year 1985, what is the difference between the Number of enrolments of both sexes in Jamaica and Number of enrolments of both sexes in Rwanda?
Your response must be concise. 8.72e+04. In the year 1985, what is the difference between the Number of enrolments of both sexes in Peru and Number of enrolments of both sexes in Rwanda?
Offer a very short reply. 1.27e+06. In the year 1986, what is the difference between the Number of enrolments of both sexes in Botswana and Number of enrolments of both sexes in Jamaica?
Ensure brevity in your answer.  -1.98e+05. In the year 1986, what is the difference between the Number of enrolments of both sexes of Botswana and Number of enrolments of both sexes of Peru?
Offer a very short reply. -1.43e+06. In the year 1986, what is the difference between the Number of enrolments of both sexes in Botswana and Number of enrolments of both sexes in Rwanda?
Your answer should be compact. -1.22e+05. In the year 1986, what is the difference between the Number of enrolments of both sexes of Jamaica and Number of enrolments of both sexes of Peru?
Provide a succinct answer. -1.24e+06. In the year 1986, what is the difference between the Number of enrolments of both sexes in Jamaica and Number of enrolments of both sexes in Rwanda?
Your response must be concise. 7.57e+04. In the year 1986, what is the difference between the Number of enrolments of both sexes in Peru and Number of enrolments of both sexes in Rwanda?
Provide a succinct answer. 1.31e+06. In the year 1987, what is the difference between the Number of enrolments of both sexes in Botswana and Number of enrolments of both sexes in Jamaica?
Ensure brevity in your answer.  -1.93e+05. In the year 1987, what is the difference between the Number of enrolments of both sexes in Botswana and Number of enrolments of both sexes in Peru?
Make the answer very short. -1.48e+06. In the year 1987, what is the difference between the Number of enrolments of both sexes of Botswana and Number of enrolments of both sexes of Rwanda?
Offer a terse response. -1.26e+05. In the year 1987, what is the difference between the Number of enrolments of both sexes of Jamaica and Number of enrolments of both sexes of Peru?
Offer a very short reply. -1.29e+06. In the year 1987, what is the difference between the Number of enrolments of both sexes in Jamaica and Number of enrolments of both sexes in Rwanda?
Ensure brevity in your answer.  6.70e+04. In the year 1987, what is the difference between the Number of enrolments of both sexes of Peru and Number of enrolments of both sexes of Rwanda?
Ensure brevity in your answer.  1.36e+06. What is the ratio of the Number of enrolments of both sexes in Botswana in 1979 to that in 1980?
Give a very brief answer. 0.93. What is the ratio of the Number of enrolments of both sexes of Jamaica in 1979 to that in 1980?
Provide a short and direct response. 0.94. What is the ratio of the Number of enrolments of both sexes of Peru in 1979 to that in 1980?
Your response must be concise. 0.96. What is the ratio of the Number of enrolments of both sexes of Rwanda in 1979 to that in 1980?
Provide a succinct answer. 0.35. What is the ratio of the Number of enrolments of both sexes in Botswana in 1979 to that in 1981?
Keep it short and to the point. 0.85. What is the ratio of the Number of enrolments of both sexes in Jamaica in 1979 to that in 1981?
Offer a very short reply. 0.97. What is the ratio of the Number of enrolments of both sexes of Peru in 1979 to that in 1981?
Your response must be concise. 0.94. What is the ratio of the Number of enrolments of both sexes of Rwanda in 1979 to that in 1981?
Keep it short and to the point. 0.23. What is the ratio of the Number of enrolments of both sexes of Botswana in 1979 to that in 1983?
Offer a very short reply. 0.78. What is the ratio of the Number of enrolments of both sexes of Jamaica in 1979 to that in 1983?
Ensure brevity in your answer.  0.99. What is the ratio of the Number of enrolments of both sexes in Peru in 1979 to that in 1983?
Keep it short and to the point. 0.87. What is the ratio of the Number of enrolments of both sexes of Rwanda in 1979 to that in 1983?
Offer a very short reply. 0.19. What is the ratio of the Number of enrolments of both sexes of Botswana in 1979 to that in 1984?
Offer a very short reply. 0.63. What is the ratio of the Number of enrolments of both sexes in Jamaica in 1979 to that in 1984?
Keep it short and to the point. 1.01. What is the ratio of the Number of enrolments of both sexes in Peru in 1979 to that in 1984?
Provide a succinct answer. 0.84. What is the ratio of the Number of enrolments of both sexes of Rwanda in 1979 to that in 1984?
Offer a very short reply. 0.18. What is the ratio of the Number of enrolments of both sexes of Botswana in 1979 to that in 1985?
Ensure brevity in your answer.  0.54. What is the ratio of the Number of enrolments of both sexes of Jamaica in 1979 to that in 1985?
Your answer should be very brief. 0.98. What is the ratio of the Number of enrolments of both sexes in Peru in 1979 to that in 1985?
Your answer should be compact. 0.81. What is the ratio of the Number of enrolments of both sexes in Rwanda in 1979 to that in 1985?
Your response must be concise. 0.16. What is the ratio of the Number of enrolments of both sexes in Botswana in 1979 to that in 1986?
Ensure brevity in your answer.  0.49. What is the ratio of the Number of enrolments of both sexes in Jamaica in 1979 to that in 1986?
Make the answer very short. 1.01. What is the ratio of the Number of enrolments of both sexes in Peru in 1979 to that in 1986?
Keep it short and to the point. 0.78. What is the ratio of the Number of enrolments of both sexes in Rwanda in 1979 to that in 1986?
Ensure brevity in your answer.  0.16. What is the ratio of the Number of enrolments of both sexes of Botswana in 1979 to that in 1987?
Keep it short and to the point. 0.45. What is the ratio of the Number of enrolments of both sexes of Jamaica in 1979 to that in 1987?
Provide a succinct answer. 1.01. What is the ratio of the Number of enrolments of both sexes of Peru in 1979 to that in 1987?
Make the answer very short. 0.76. What is the ratio of the Number of enrolments of both sexes in Rwanda in 1979 to that in 1987?
Your answer should be very brief. 0.15. What is the ratio of the Number of enrolments of both sexes in Botswana in 1980 to that in 1981?
Ensure brevity in your answer.  0.91. What is the ratio of the Number of enrolments of both sexes in Jamaica in 1980 to that in 1981?
Provide a succinct answer. 1.03. What is the ratio of the Number of enrolments of both sexes of Peru in 1980 to that in 1981?
Offer a terse response. 0.98. What is the ratio of the Number of enrolments of both sexes of Rwanda in 1980 to that in 1981?
Provide a short and direct response. 0.65. What is the ratio of the Number of enrolments of both sexes of Botswana in 1980 to that in 1983?
Provide a succinct answer. 0.84. What is the ratio of the Number of enrolments of both sexes in Jamaica in 1980 to that in 1983?
Your answer should be very brief. 1.05. What is the ratio of the Number of enrolments of both sexes of Peru in 1980 to that in 1983?
Provide a succinct answer. 0.91. What is the ratio of the Number of enrolments of both sexes in Rwanda in 1980 to that in 1983?
Your response must be concise. 0.54. What is the ratio of the Number of enrolments of both sexes in Botswana in 1980 to that in 1984?
Your answer should be compact. 0.68. What is the ratio of the Number of enrolments of both sexes in Jamaica in 1980 to that in 1984?
Make the answer very short. 1.07. What is the ratio of the Number of enrolments of both sexes of Peru in 1980 to that in 1984?
Give a very brief answer. 0.88. What is the ratio of the Number of enrolments of both sexes of Rwanda in 1980 to that in 1984?
Give a very brief answer. 0.51. What is the ratio of the Number of enrolments of both sexes in Botswana in 1980 to that in 1985?
Ensure brevity in your answer.  0.58. What is the ratio of the Number of enrolments of both sexes in Jamaica in 1980 to that in 1985?
Ensure brevity in your answer.  1.05. What is the ratio of the Number of enrolments of both sexes of Peru in 1980 to that in 1985?
Your response must be concise. 0.84. What is the ratio of the Number of enrolments of both sexes of Rwanda in 1980 to that in 1985?
Your answer should be compact. 0.46. What is the ratio of the Number of enrolments of both sexes in Botswana in 1980 to that in 1986?
Offer a very short reply. 0.53. What is the ratio of the Number of enrolments of both sexes of Jamaica in 1980 to that in 1986?
Offer a very short reply. 1.07. What is the ratio of the Number of enrolments of both sexes of Peru in 1980 to that in 1986?
Your response must be concise. 0.82. What is the ratio of the Number of enrolments of both sexes of Rwanda in 1980 to that in 1986?
Keep it short and to the point. 0.45. What is the ratio of the Number of enrolments of both sexes of Botswana in 1980 to that in 1987?
Provide a short and direct response. 0.49. What is the ratio of the Number of enrolments of both sexes in Jamaica in 1980 to that in 1987?
Your answer should be compact. 1.08. What is the ratio of the Number of enrolments of both sexes in Peru in 1980 to that in 1987?
Offer a terse response. 0.79. What is the ratio of the Number of enrolments of both sexes of Rwanda in 1980 to that in 1987?
Make the answer very short. 0.43. What is the ratio of the Number of enrolments of both sexes of Botswana in 1981 to that in 1983?
Keep it short and to the point. 0.92. What is the ratio of the Number of enrolments of both sexes of Jamaica in 1981 to that in 1983?
Your answer should be very brief. 1.02. What is the ratio of the Number of enrolments of both sexes of Peru in 1981 to that in 1983?
Make the answer very short. 0.93. What is the ratio of the Number of enrolments of both sexes of Rwanda in 1981 to that in 1983?
Your response must be concise. 0.83. What is the ratio of the Number of enrolments of both sexes in Botswana in 1981 to that in 1984?
Provide a succinct answer. 0.74. What is the ratio of the Number of enrolments of both sexes of Jamaica in 1981 to that in 1984?
Your response must be concise. 1.04. What is the ratio of the Number of enrolments of both sexes of Peru in 1981 to that in 1984?
Make the answer very short. 0.89. What is the ratio of the Number of enrolments of both sexes in Rwanda in 1981 to that in 1984?
Give a very brief answer. 0.79. What is the ratio of the Number of enrolments of both sexes in Botswana in 1981 to that in 1985?
Ensure brevity in your answer.  0.64. What is the ratio of the Number of enrolments of both sexes in Jamaica in 1981 to that in 1985?
Provide a succinct answer. 1.02. What is the ratio of the Number of enrolments of both sexes of Peru in 1981 to that in 1985?
Provide a short and direct response. 0.86. What is the ratio of the Number of enrolments of both sexes of Rwanda in 1981 to that in 1985?
Keep it short and to the point. 0.71. What is the ratio of the Number of enrolments of both sexes of Botswana in 1981 to that in 1986?
Your response must be concise. 0.58. What is the ratio of the Number of enrolments of both sexes of Jamaica in 1981 to that in 1986?
Give a very brief answer. 1.04. What is the ratio of the Number of enrolments of both sexes in Peru in 1981 to that in 1986?
Your answer should be very brief. 0.83. What is the ratio of the Number of enrolments of both sexes in Rwanda in 1981 to that in 1986?
Make the answer very short. 0.68. What is the ratio of the Number of enrolments of both sexes of Botswana in 1981 to that in 1987?
Offer a very short reply. 0.53. What is the ratio of the Number of enrolments of both sexes of Jamaica in 1981 to that in 1987?
Provide a short and direct response. 1.05. What is the ratio of the Number of enrolments of both sexes of Peru in 1981 to that in 1987?
Your answer should be very brief. 0.8. What is the ratio of the Number of enrolments of both sexes of Rwanda in 1981 to that in 1987?
Provide a short and direct response. 0.65. What is the ratio of the Number of enrolments of both sexes of Botswana in 1983 to that in 1984?
Provide a succinct answer. 0.81. What is the ratio of the Number of enrolments of both sexes in Jamaica in 1983 to that in 1984?
Your answer should be very brief. 1.02. What is the ratio of the Number of enrolments of both sexes of Peru in 1983 to that in 1984?
Provide a short and direct response. 0.96. What is the ratio of the Number of enrolments of both sexes in Rwanda in 1983 to that in 1984?
Offer a terse response. 0.95. What is the ratio of the Number of enrolments of both sexes in Botswana in 1983 to that in 1985?
Make the answer very short. 0.69. What is the ratio of the Number of enrolments of both sexes of Jamaica in 1983 to that in 1985?
Your answer should be compact. 1. What is the ratio of the Number of enrolments of both sexes in Peru in 1983 to that in 1985?
Your answer should be very brief. 0.93. What is the ratio of the Number of enrolments of both sexes of Rwanda in 1983 to that in 1985?
Offer a very short reply. 0.85. What is the ratio of the Number of enrolments of both sexes of Botswana in 1983 to that in 1986?
Your answer should be compact. 0.63. What is the ratio of the Number of enrolments of both sexes in Jamaica in 1983 to that in 1986?
Offer a terse response. 1.02. What is the ratio of the Number of enrolments of both sexes in Peru in 1983 to that in 1986?
Your response must be concise. 0.9. What is the ratio of the Number of enrolments of both sexes in Rwanda in 1983 to that in 1986?
Make the answer very short. 0.82. What is the ratio of the Number of enrolments of both sexes in Botswana in 1983 to that in 1987?
Give a very brief answer. 0.58. What is the ratio of the Number of enrolments of both sexes in Jamaica in 1983 to that in 1987?
Offer a very short reply. 1.03. What is the ratio of the Number of enrolments of both sexes of Peru in 1983 to that in 1987?
Offer a very short reply. 0.87. What is the ratio of the Number of enrolments of both sexes of Rwanda in 1983 to that in 1987?
Your answer should be very brief. 0.79. What is the ratio of the Number of enrolments of both sexes of Botswana in 1984 to that in 1985?
Offer a terse response. 0.85. What is the ratio of the Number of enrolments of both sexes in Jamaica in 1984 to that in 1985?
Keep it short and to the point. 0.98. What is the ratio of the Number of enrolments of both sexes in Peru in 1984 to that in 1985?
Provide a succinct answer. 0.96. What is the ratio of the Number of enrolments of both sexes of Rwanda in 1984 to that in 1985?
Your response must be concise. 0.9. What is the ratio of the Number of enrolments of both sexes in Botswana in 1984 to that in 1986?
Ensure brevity in your answer.  0.78. What is the ratio of the Number of enrolments of both sexes in Peru in 1984 to that in 1986?
Your response must be concise. 0.93. What is the ratio of the Number of enrolments of both sexes of Rwanda in 1984 to that in 1986?
Your answer should be compact. 0.87. What is the ratio of the Number of enrolments of both sexes in Botswana in 1984 to that in 1987?
Offer a very short reply. 0.72. What is the ratio of the Number of enrolments of both sexes in Peru in 1984 to that in 1987?
Offer a very short reply. 0.9. What is the ratio of the Number of enrolments of both sexes of Rwanda in 1984 to that in 1987?
Your response must be concise. 0.83. What is the ratio of the Number of enrolments of both sexes of Botswana in 1985 to that in 1986?
Offer a terse response. 0.91. What is the ratio of the Number of enrolments of both sexes of Jamaica in 1985 to that in 1986?
Make the answer very short. 1.02. What is the ratio of the Number of enrolments of both sexes of Peru in 1985 to that in 1986?
Ensure brevity in your answer.  0.97. What is the ratio of the Number of enrolments of both sexes of Rwanda in 1985 to that in 1986?
Give a very brief answer. 0.96. What is the ratio of the Number of enrolments of both sexes of Botswana in 1985 to that in 1987?
Make the answer very short. 0.84. What is the ratio of the Number of enrolments of both sexes in Jamaica in 1985 to that in 1987?
Provide a succinct answer. 1.03. What is the ratio of the Number of enrolments of both sexes in Peru in 1985 to that in 1987?
Provide a short and direct response. 0.94. What is the ratio of the Number of enrolments of both sexes in Rwanda in 1985 to that in 1987?
Keep it short and to the point. 0.92. What is the ratio of the Number of enrolments of both sexes of Botswana in 1986 to that in 1987?
Ensure brevity in your answer.  0.92. What is the ratio of the Number of enrolments of both sexes in Jamaica in 1986 to that in 1987?
Offer a terse response. 1.01. What is the ratio of the Number of enrolments of both sexes in Peru in 1986 to that in 1987?
Provide a succinct answer. 0.97. What is the ratio of the Number of enrolments of both sexes of Rwanda in 1986 to that in 1987?
Offer a very short reply. 0.96. What is the difference between the highest and the second highest Number of enrolments of both sexes of Botswana?
Ensure brevity in your answer.  3239. What is the difference between the highest and the second highest Number of enrolments of both sexes in Jamaica?
Provide a succinct answer. 7230. What is the difference between the highest and the second highest Number of enrolments of both sexes of Peru?
Ensure brevity in your answer.  5.09e+04. What is the difference between the highest and the second highest Number of enrolments of both sexes of Rwanda?
Offer a very short reply. 7324. What is the difference between the highest and the lowest Number of enrolments of both sexes in Botswana?
Your response must be concise. 2.34e+04. What is the difference between the highest and the lowest Number of enrolments of both sexes in Jamaica?
Provide a succinct answer. 1.88e+04. What is the difference between the highest and the lowest Number of enrolments of both sexes in Peru?
Offer a terse response. 3.73e+05. What is the difference between the highest and the lowest Number of enrolments of both sexes in Rwanda?
Offer a very short reply. 1.44e+05. 